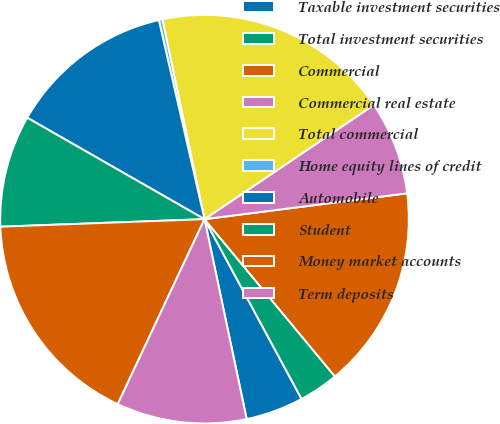Convert chart to OTSL. <chart><loc_0><loc_0><loc_500><loc_500><pie_chart><fcel>Taxable investment securities<fcel>Total investment securities<fcel>Commercial<fcel>Commercial real estate<fcel>Total commercial<fcel>Home equity lines of credit<fcel>Automobile<fcel>Student<fcel>Money market accounts<fcel>Term deposits<nl><fcel>4.57%<fcel>3.14%<fcel>16.0%<fcel>7.43%<fcel>18.86%<fcel>0.28%<fcel>13.14%<fcel>8.86%<fcel>17.43%<fcel>10.29%<nl></chart> 